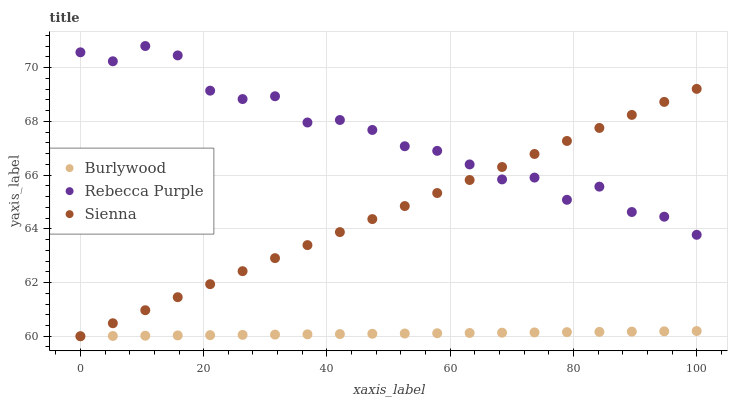Does Burlywood have the minimum area under the curve?
Answer yes or no. Yes. Does Rebecca Purple have the maximum area under the curve?
Answer yes or no. Yes. Does Sienna have the minimum area under the curve?
Answer yes or no. No. Does Sienna have the maximum area under the curve?
Answer yes or no. No. Is Burlywood the smoothest?
Answer yes or no. Yes. Is Rebecca Purple the roughest?
Answer yes or no. Yes. Is Sienna the smoothest?
Answer yes or no. No. Is Sienna the roughest?
Answer yes or no. No. Does Burlywood have the lowest value?
Answer yes or no. Yes. Does Rebecca Purple have the lowest value?
Answer yes or no. No. Does Rebecca Purple have the highest value?
Answer yes or no. Yes. Does Sienna have the highest value?
Answer yes or no. No. Is Burlywood less than Rebecca Purple?
Answer yes or no. Yes. Is Rebecca Purple greater than Burlywood?
Answer yes or no. Yes. Does Sienna intersect Burlywood?
Answer yes or no. Yes. Is Sienna less than Burlywood?
Answer yes or no. No. Is Sienna greater than Burlywood?
Answer yes or no. No. Does Burlywood intersect Rebecca Purple?
Answer yes or no. No. 